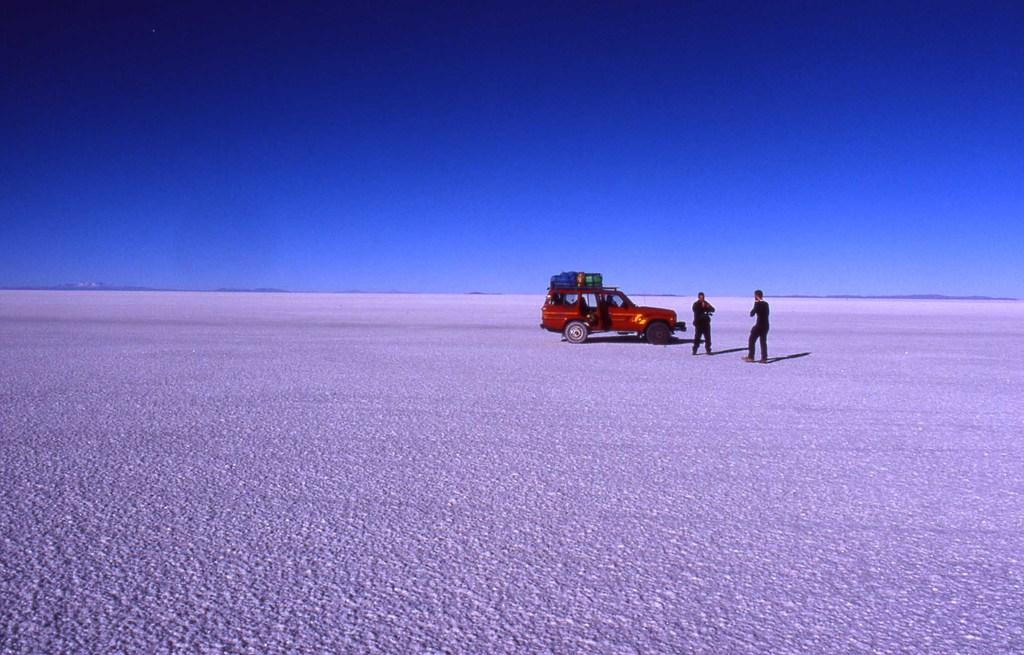What type of vehicle is in the image? There is a red car in the image. What is on the car? There is luggage on the car. How many people are in the image? There are two persons in the image. What can be seen in the background of the image? The sky is visible in the image. What type of trade is being conducted in the image? There is no indication of any trade being conducted in the image; it features a red car with luggage and two people. Can you see any nails in the image? There are no nails visible in the image. 